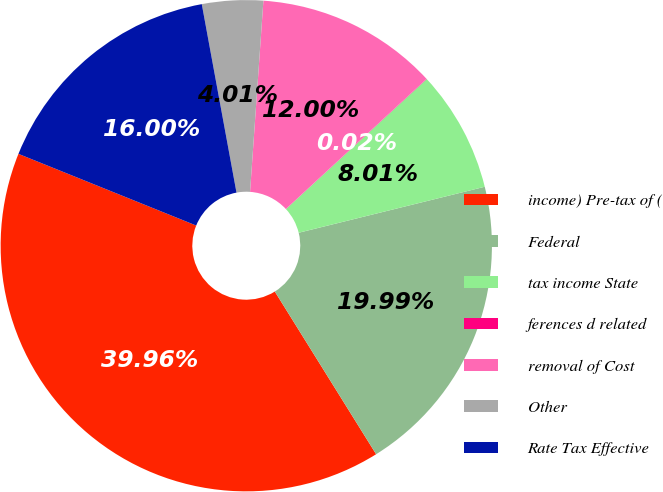<chart> <loc_0><loc_0><loc_500><loc_500><pie_chart><fcel>income) Pre-tax of (<fcel>Federal<fcel>tax income State<fcel>ferences d related<fcel>removal of Cost<fcel>Other<fcel>Rate Tax Effective<nl><fcel>39.96%<fcel>19.99%<fcel>8.01%<fcel>0.02%<fcel>12.0%<fcel>4.01%<fcel>16.0%<nl></chart> 